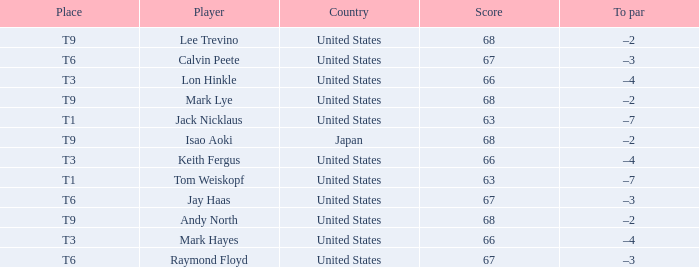For the player "lee trevino" representing the "united states", what is the overall score? 1.0. 